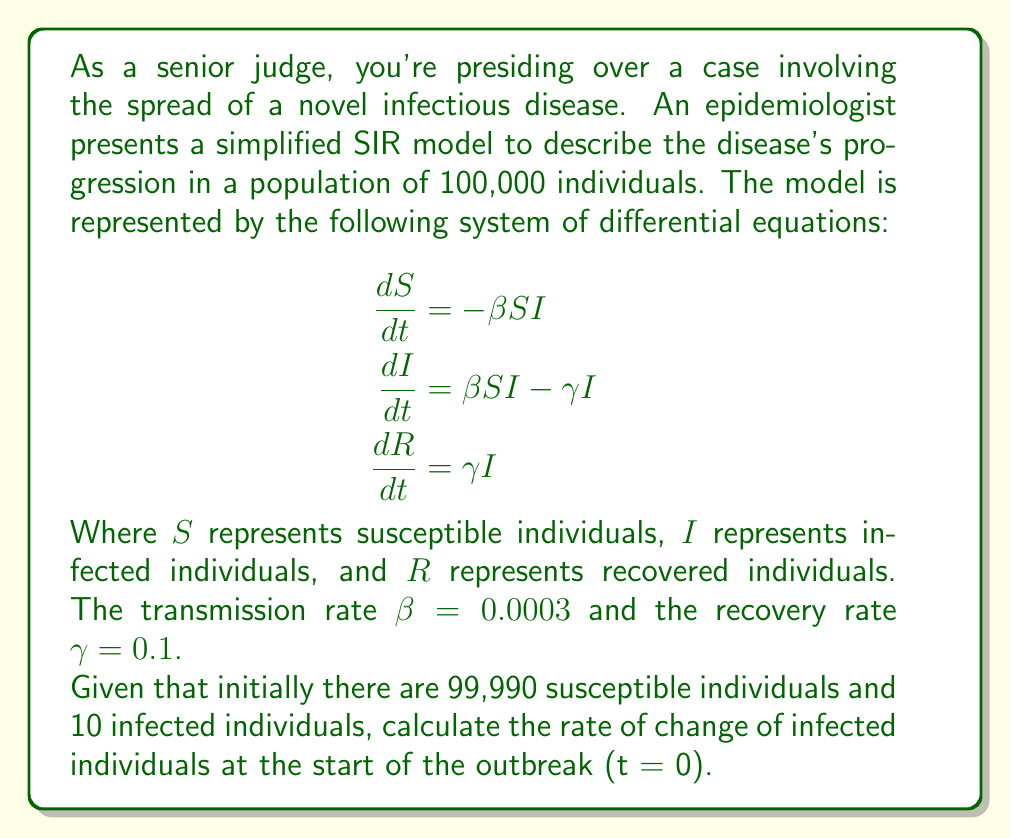Help me with this question. To solve this problem, we'll follow these steps:

1) First, recall the equation for the rate of change of infected individuals:

   $$\frac{dI}{dt} = \beta SI - \gamma I$$

2) We need to substitute the given values:
   - $\beta = 0.0003$
   - $\gamma = 0.1$
   - $S = 99,990$ (at t = 0)
   - $I = 10$ (at t = 0)

3) Let's substitute these values into the equation:

   $$\frac{dI}{dt} = (0.0003)(99,990)(10) - (0.1)(10)$$

4) Now, let's calculate step by step:
   - First, multiply within the parentheses:
     $$(0.0003)(99,990)(10) = 299.97$$
     $$(0.1)(10) = 1$$

   - Now our equation looks like:
     $$\frac{dI}{dt} = 299.97 - 1$$

5) Perform the final subtraction:
   $$\frac{dI}{dt} = 298.97$$

Therefore, at the start of the outbreak (t = 0), the rate of change of infected individuals is 298.97 individuals per unit time.
Answer: 298.97 individuals per unit time 